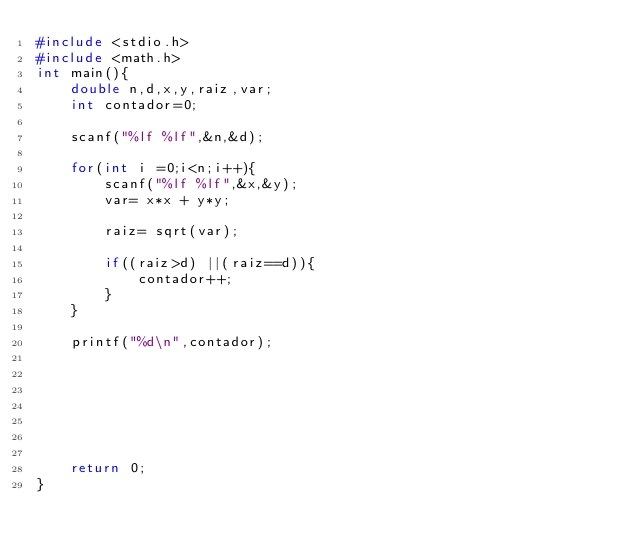<code> <loc_0><loc_0><loc_500><loc_500><_C_>#include <stdio.h>
#include <math.h>
int main(){
    double n,d,x,y,raiz,var;
    int contador=0;

    scanf("%lf %lf",&n,&d);

    for(int i =0;i<n;i++){
        scanf("%lf %lf",&x,&y);
        var= x*x + y*y;

        raiz= sqrt(var);

        if((raiz>d) ||(raiz==d)){
            contador++;
        }
    }

    printf("%d\n",contador);







    return 0;
}
</code> 